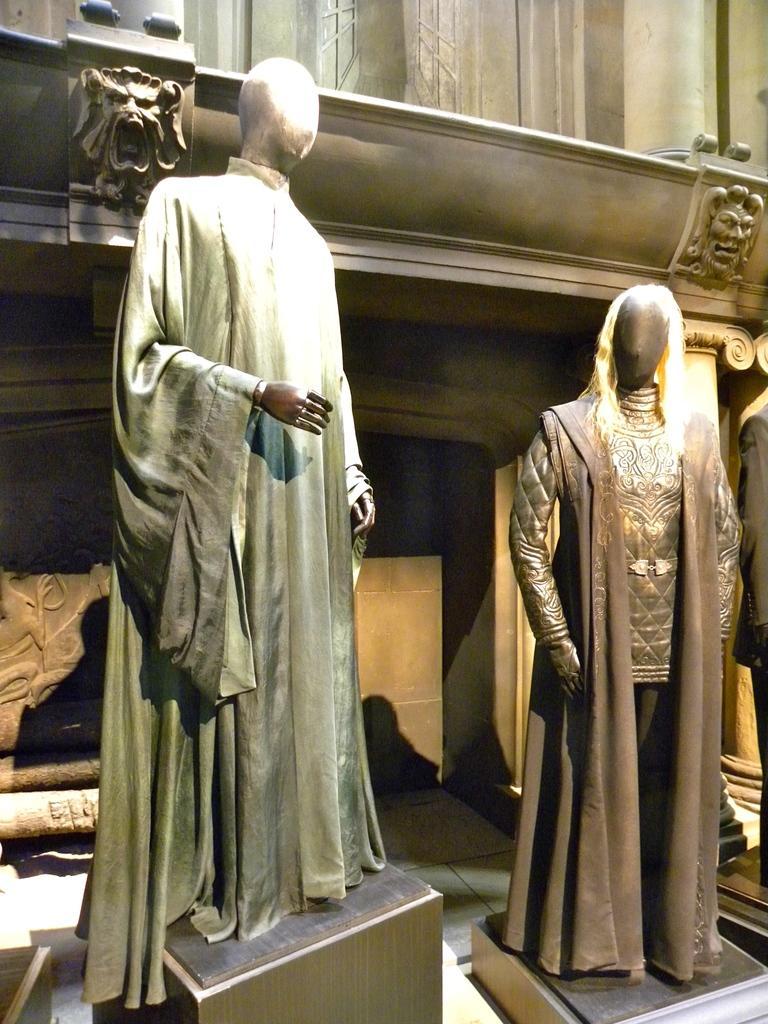How would you summarize this image in a sentence or two? In this picture we can see couple of mannequins with clothes on them, in the background we can see two symbols. 